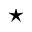Convert formula to latex. <formula><loc_0><loc_0><loc_500><loc_500>^ { * }</formula> 